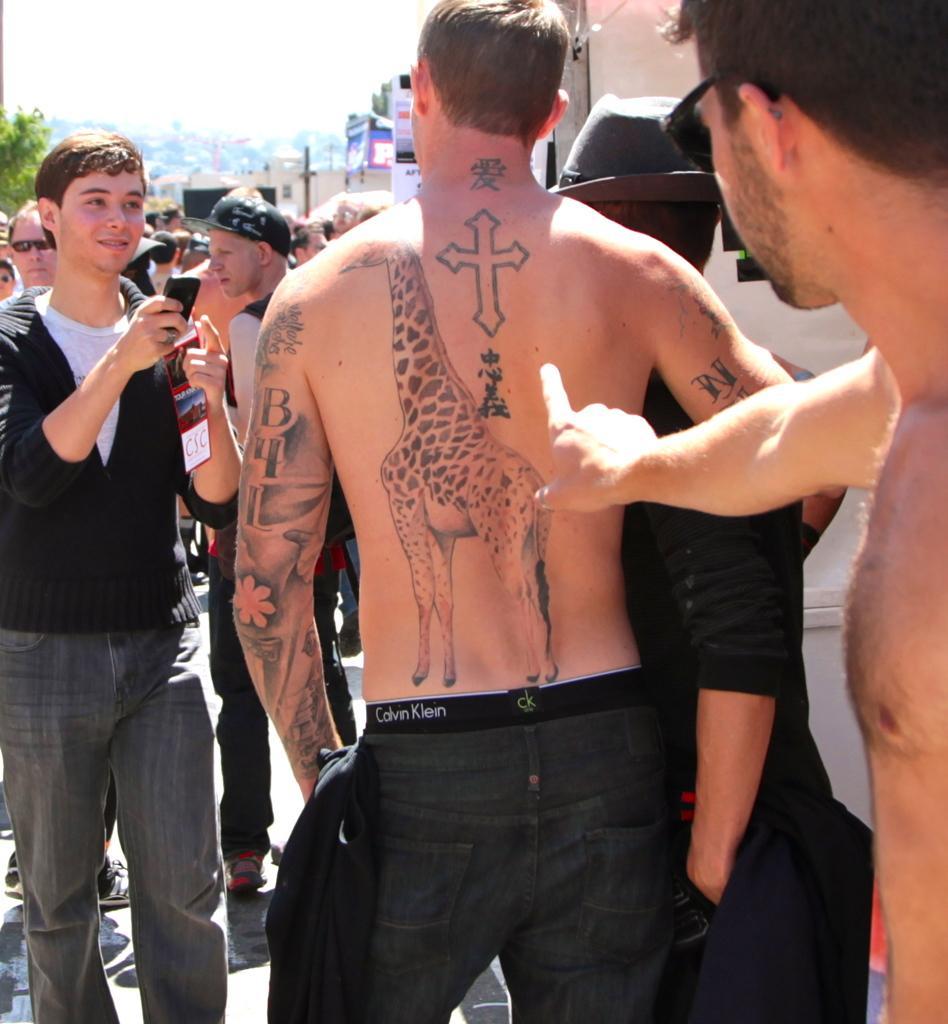Can you describe this image briefly? This picture is clicked outside on the ground. In the center we can see the group of people seems to be standing on the ground. In the background we can see the sky, tree and the buildings and some poles. 